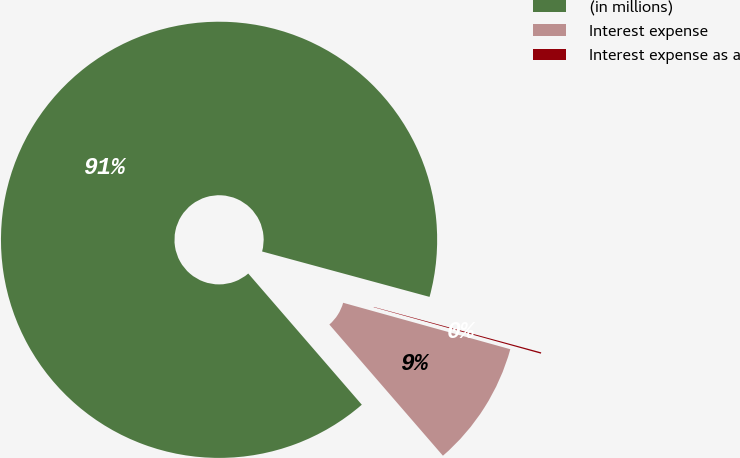Convert chart to OTSL. <chart><loc_0><loc_0><loc_500><loc_500><pie_chart><fcel>(in millions)<fcel>Interest expense<fcel>Interest expense as a<nl><fcel>90.57%<fcel>9.33%<fcel>0.1%<nl></chart> 